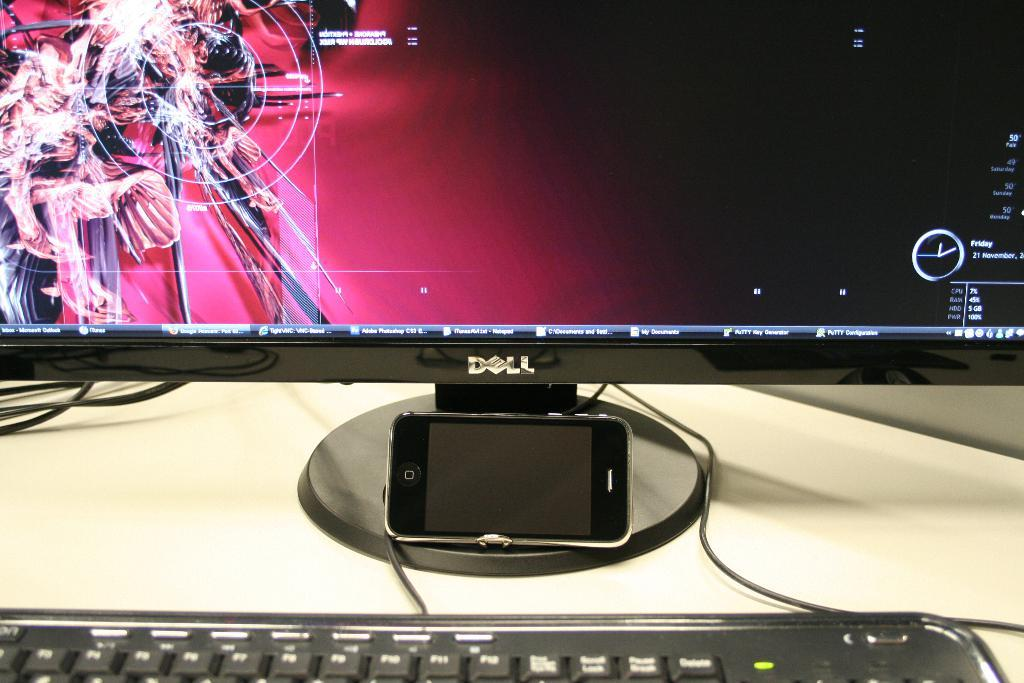<image>
Summarize the visual content of the image. A Dell brand computer with a large monitor. 